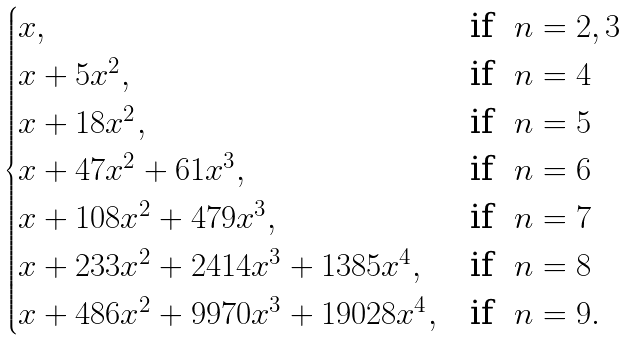Convert formula to latex. <formula><loc_0><loc_0><loc_500><loc_500>\begin{cases} x , & \text {if \ $n=2, 3$} \\ x + 5 x ^ { 2 } , & \text {if \ $n=4$} \\ x + 1 8 x ^ { 2 } , & \text {if \ $n=5$} \\ x + 4 7 x ^ { 2 } + 6 1 x ^ { 3 } , & \text {if \ $n=6$} \\ x + 1 0 8 x ^ { 2 } + 4 7 9 x ^ { 3 } , & \text {if \ $n=7$} \\ x + 2 3 3 x ^ { 2 } + 2 4 1 4 x ^ { 3 } + 1 3 8 5 x ^ { 4 } , & \text {if \ $n=8$} \\ x + 4 8 6 x ^ { 2 } + 9 9 7 0 x ^ { 3 } + 1 9 0 2 8 x ^ { 4 } , & \text {if \ $n=9$} . \end{cases}</formula> 